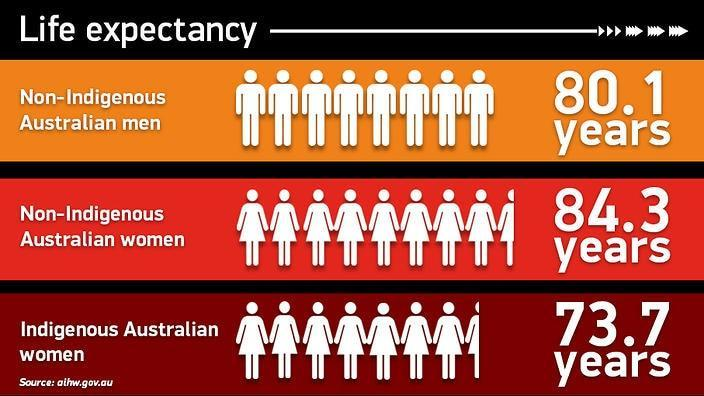What is the difference in the life expectancy of non-indigenous women and men in Australia ?
Answer the question with a short phrase. 4.2 years What is the difference in life expectancy between the non-indigenous Australian women and Indigenous Australian women? 10.6 